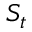Convert formula to latex. <formula><loc_0><loc_0><loc_500><loc_500>S _ { t }</formula> 